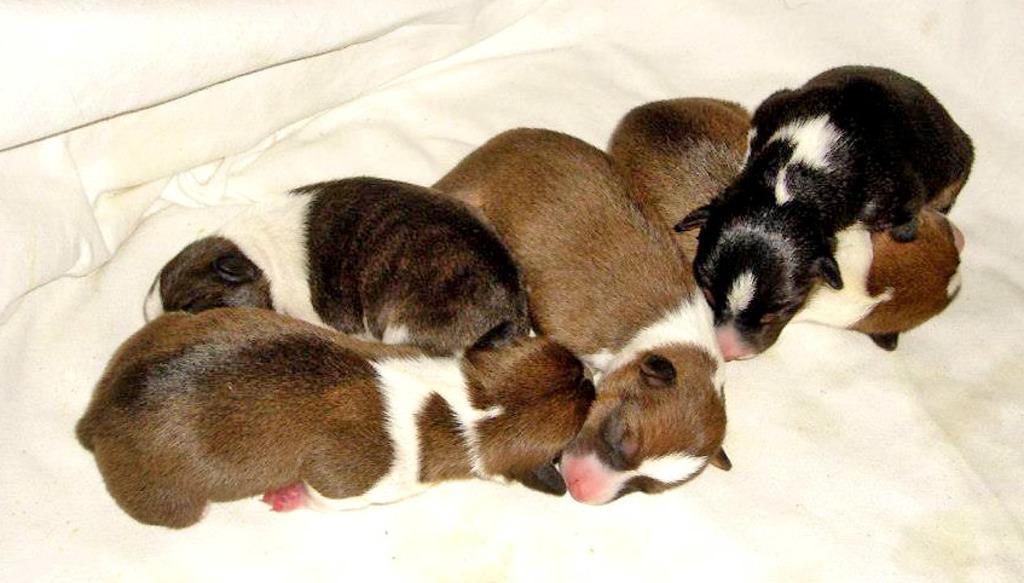In one or two sentences, can you explain what this image depicts? We can see dogs on white cloth. 